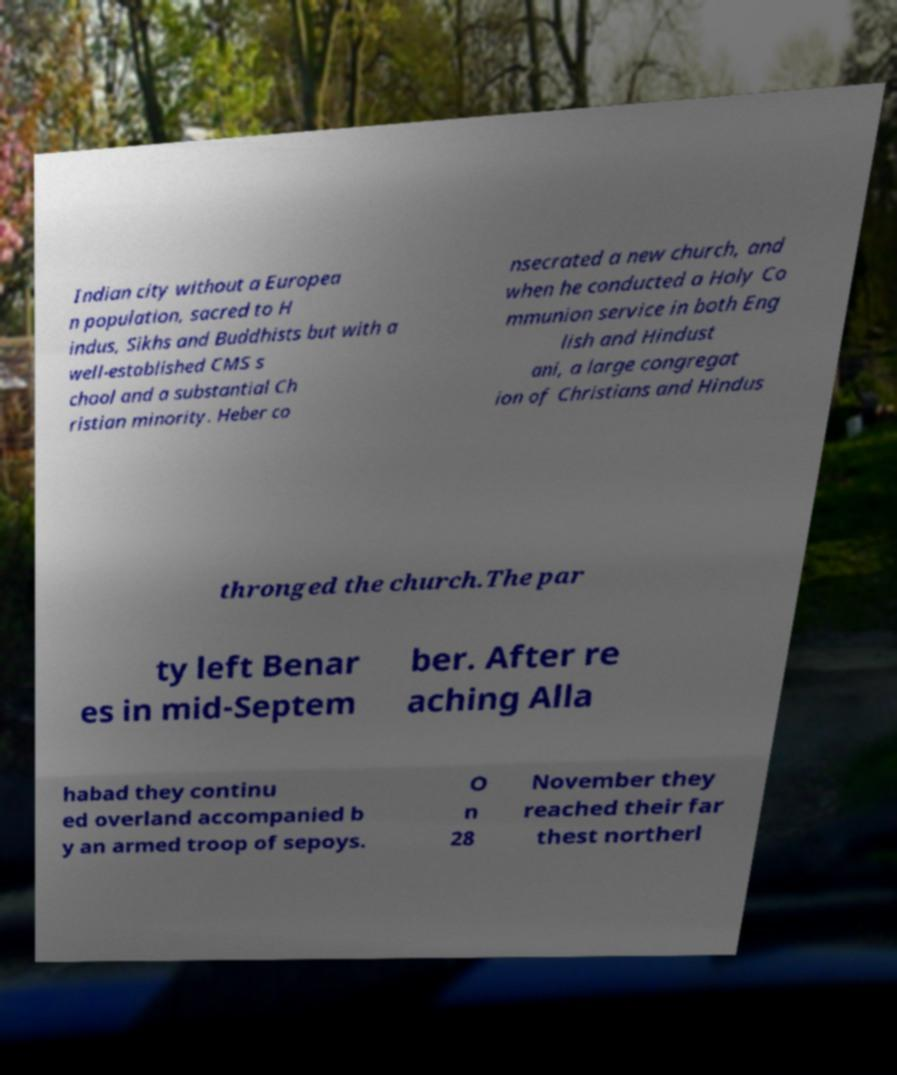Could you assist in decoding the text presented in this image and type it out clearly? Indian city without a Europea n population, sacred to H indus, Sikhs and Buddhists but with a well-established CMS s chool and a substantial Ch ristian minority. Heber co nsecrated a new church, and when he conducted a Holy Co mmunion service in both Eng lish and Hindust ani, a large congregat ion of Christians and Hindus thronged the church.The par ty left Benar es in mid-Septem ber. After re aching Alla habad they continu ed overland accompanied b y an armed troop of sepoys. O n 28 November they reached their far thest northerl 